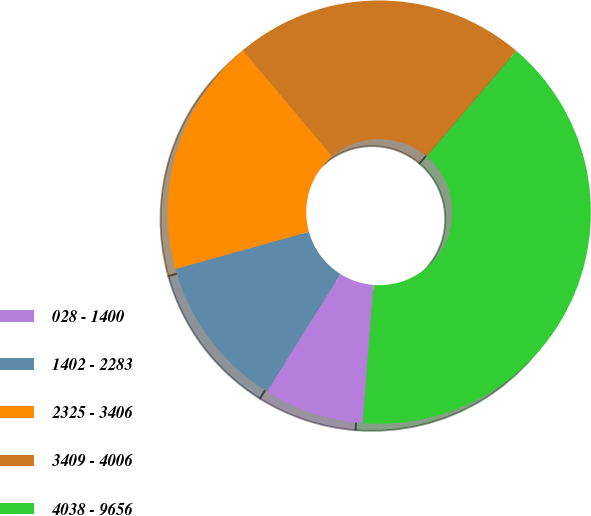Convert chart. <chart><loc_0><loc_0><loc_500><loc_500><pie_chart><fcel>028 - 1400<fcel>1402 - 2283<fcel>2325 - 3406<fcel>3409 - 4006<fcel>4038 - 9656<nl><fcel>7.65%<fcel>11.77%<fcel>18.19%<fcel>22.36%<fcel>40.04%<nl></chart> 